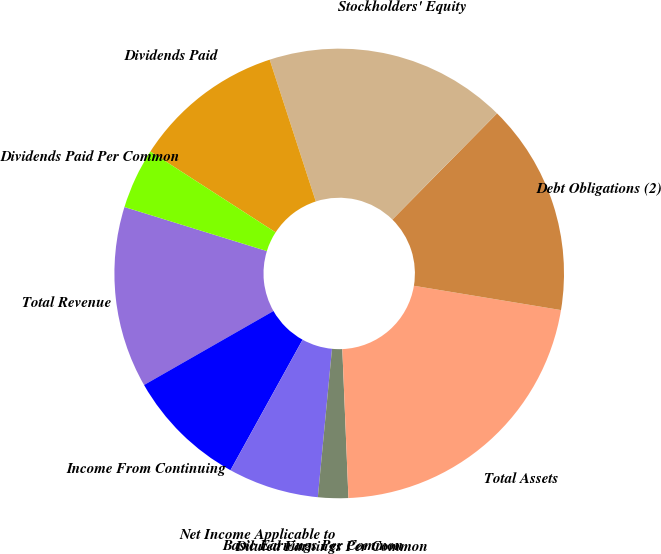<chart> <loc_0><loc_0><loc_500><loc_500><pie_chart><fcel>Total Revenue<fcel>Income From Continuing<fcel>Net Income Applicable to<fcel>Basic Earnings Per Common<fcel>Diluted Earnings Per Common<fcel>Total Assets<fcel>Debt Obligations (2)<fcel>Stockholders' Equity<fcel>Dividends Paid<fcel>Dividends Paid Per Common<nl><fcel>13.04%<fcel>8.7%<fcel>6.52%<fcel>0.0%<fcel>2.17%<fcel>21.74%<fcel>15.22%<fcel>17.39%<fcel>10.87%<fcel>4.35%<nl></chart> 